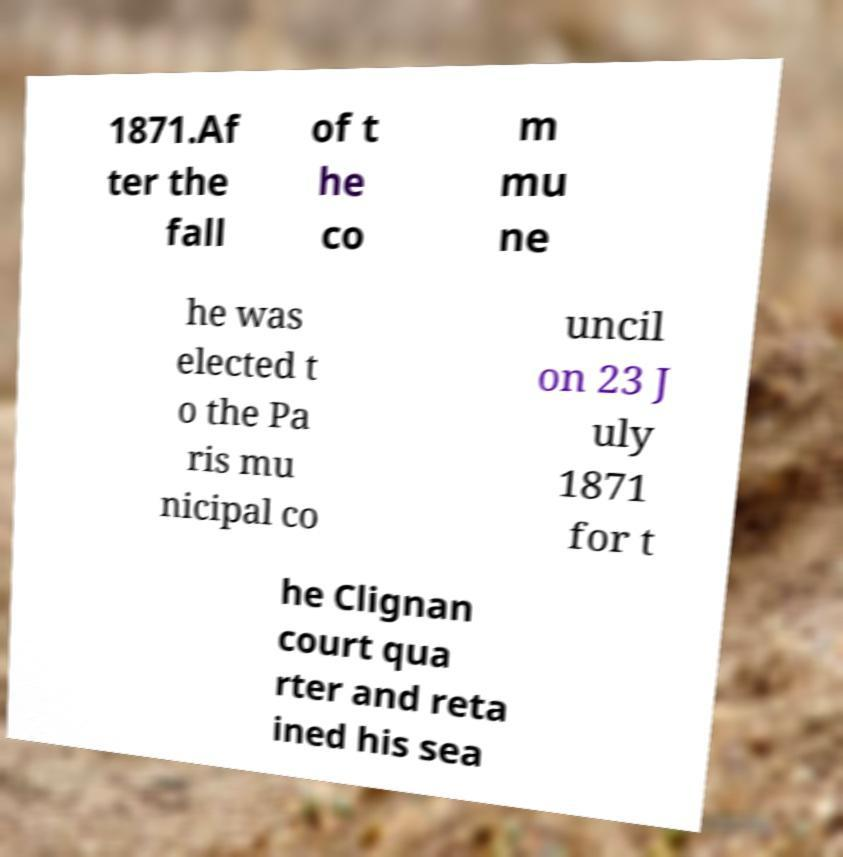There's text embedded in this image that I need extracted. Can you transcribe it verbatim? 1871.Af ter the fall of t he co m mu ne he was elected t o the Pa ris mu nicipal co uncil on 23 J uly 1871 for t he Clignan court qua rter and reta ined his sea 